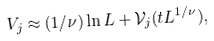<formula> <loc_0><loc_0><loc_500><loc_500>V _ { j } \approx ( 1 / \nu ) \ln L + { \mathcal { V } } _ { j } ( t L ^ { 1 / \nu } ) ,</formula> 